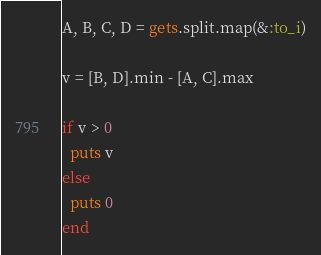<code> <loc_0><loc_0><loc_500><loc_500><_Ruby_>A, B, C, D = gets.split.map(&:to_i)

v = [B, D].min - [A, C].max

if v > 0
  puts v
else
  puts 0
end</code> 